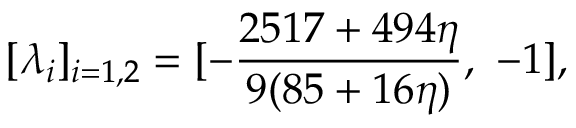<formula> <loc_0><loc_0><loc_500><loc_500>[ \lambda _ { i } ] _ { i = 1 , 2 } = [ - { \frac { 2 5 1 7 + 4 9 4 \eta } { 9 ( 8 5 + 1 6 \eta ) } } , - 1 ] ,</formula> 